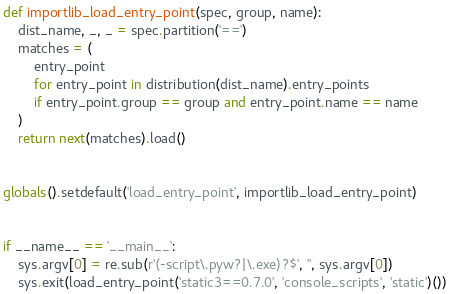Convert code to text. <code><loc_0><loc_0><loc_500><loc_500><_Python_>

def importlib_load_entry_point(spec, group, name):
    dist_name, _, _ = spec.partition('==')
    matches = (
        entry_point
        for entry_point in distribution(dist_name).entry_points
        if entry_point.group == group and entry_point.name == name
    )
    return next(matches).load()


globals().setdefault('load_entry_point', importlib_load_entry_point)


if __name__ == '__main__':
    sys.argv[0] = re.sub(r'(-script\.pyw?|\.exe)?$', '', sys.argv[0])
    sys.exit(load_entry_point('static3==0.7.0', 'console_scripts', 'static')())
</code> 